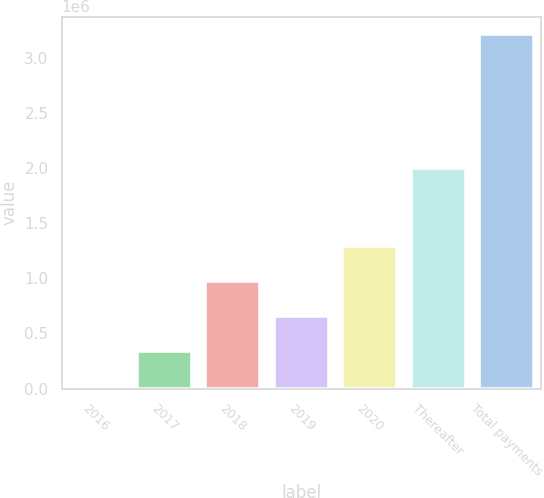Convert chart. <chart><loc_0><loc_0><loc_500><loc_500><bar_chart><fcel>2016<fcel>2017<fcel>2018<fcel>2019<fcel>2020<fcel>Thereafter<fcel>Total payments<nl><fcel>17500<fcel>336875<fcel>975625<fcel>656250<fcel>1.295e+06<fcel>2e+06<fcel>3.21125e+06<nl></chart> 